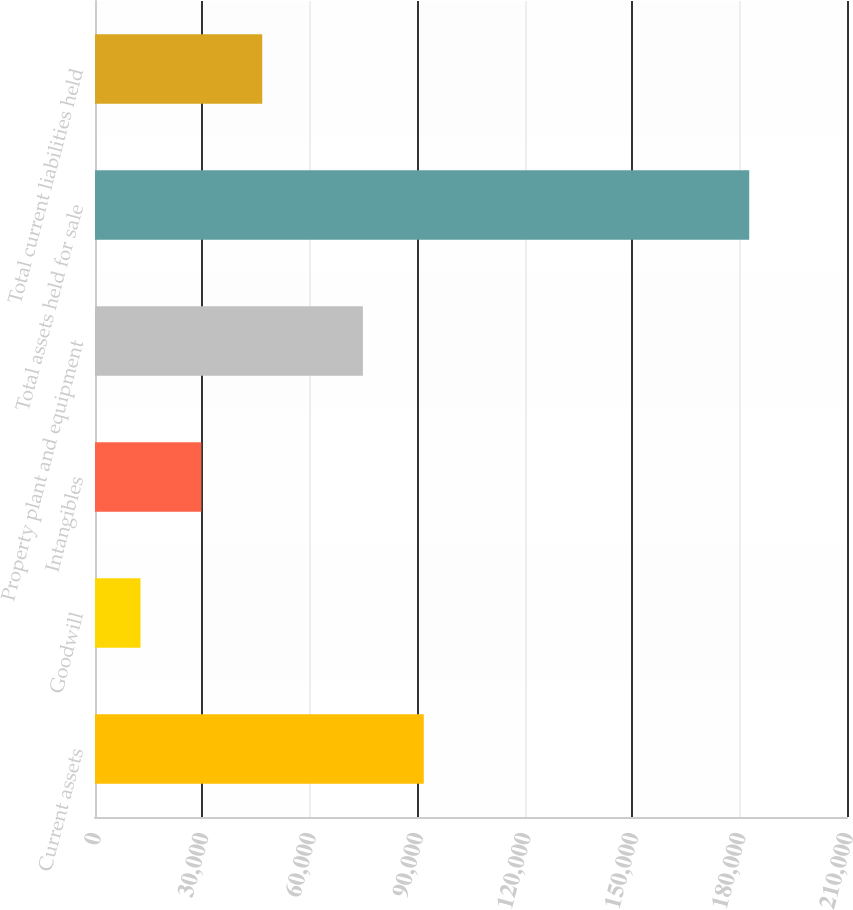<chart> <loc_0><loc_0><loc_500><loc_500><bar_chart><fcel>Current assets<fcel>Goodwill<fcel>Intangibles<fcel>Property plant and equipment<fcel>Total assets held for sale<fcel>Total current liabilities held<nl><fcel>91811.4<fcel>12703<fcel>29702.4<fcel>74812<fcel>182697<fcel>46701.8<nl></chart> 